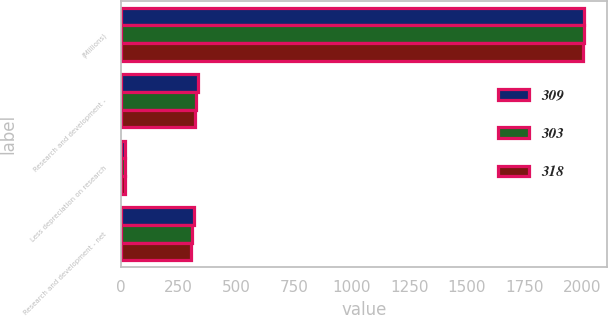<chart> <loc_0><loc_0><loc_500><loc_500><stacked_bar_chart><ecel><fcel>(Millions)<fcel>Research and development -<fcel>Less depreciation on research<fcel>Research and development - net<nl><fcel>309<fcel>2006<fcel>334<fcel>16<fcel>318<nl><fcel>303<fcel>2005<fcel>325<fcel>16<fcel>309<nl><fcel>318<fcel>2004<fcel>321<fcel>18<fcel>303<nl></chart> 